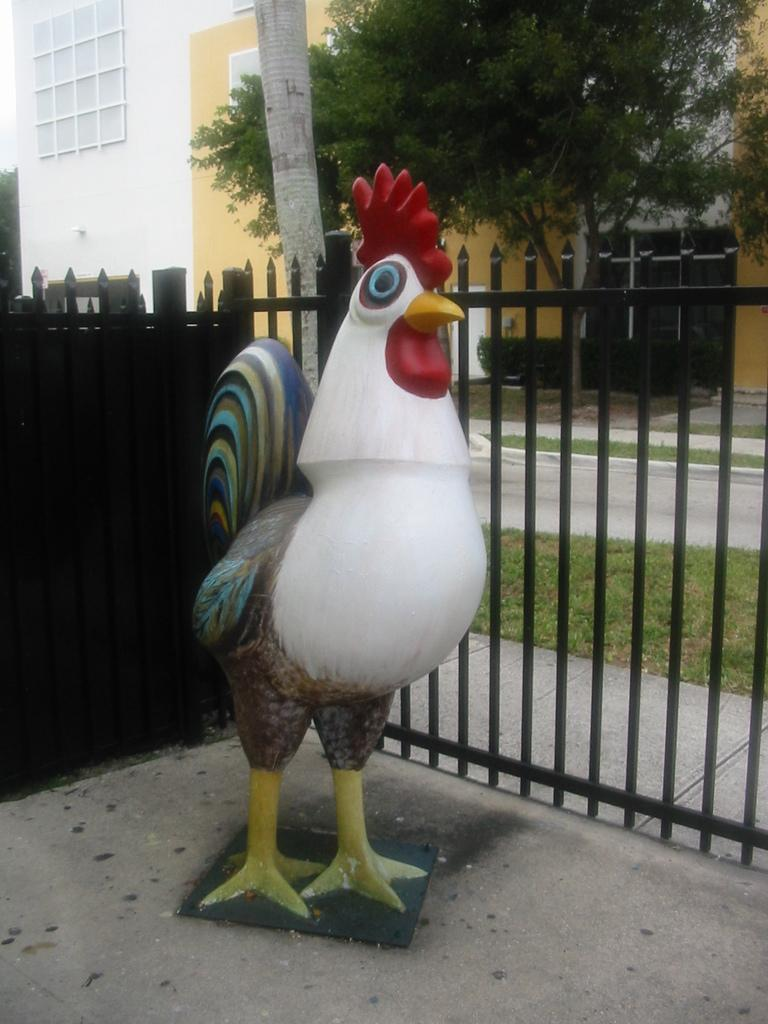What animal is depicted in the image? There is a depiction of a chicken in the image. What type of structure can be seen in the image? There are iron bars visible in the image, which might be part of a structure. What type of vegetation is present in the image? There is grass and a tree in the image. What type of man-made structures are visible in the image? There are buildings in the image. What other type of vegetation is present in the image? There are bushes in the image. How many yams are being carried by the plane in the image? There is no plane present in the image, and therefore no yams being carried by a plane. How many men are visible in the image? There is no mention of men in the provided facts, so we cannot determine how many men are visible in the image. 